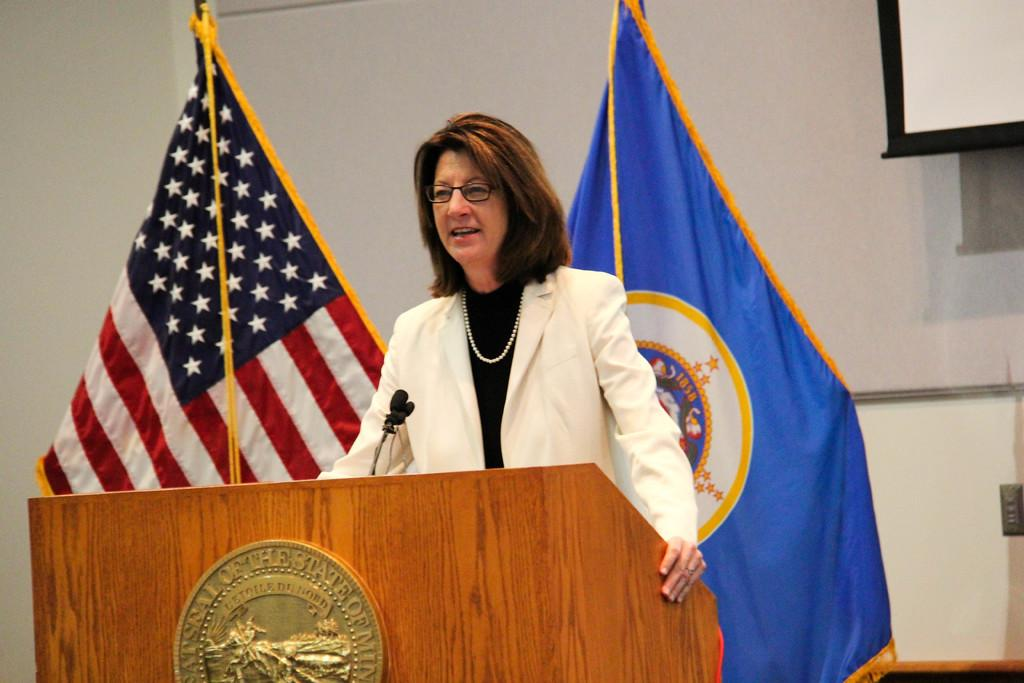What is the woman in the image doing? The woman is standing in front of a microphone. What object is in front of the woman that she might be using? There is a microphone in front of the woman. What is on the podium in front of the woman? There is a board on a podium in front of the woman. What can be seen behind the woman? There are flags and a wall visible behind the woman. What color is the banner behind the woman? There is a white banner visible behind the woman. What type of iron is being used to tie a knot in the image? There is no iron or knot present in the image. Can you identify the actor in the image? There is no actor present in the image. 